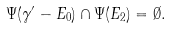<formula> <loc_0><loc_0><loc_500><loc_500>\Psi ( \gamma ^ { \prime } - E _ { 0 } ) \cap \Psi ( E _ { 2 } ) = \emptyset .</formula> 